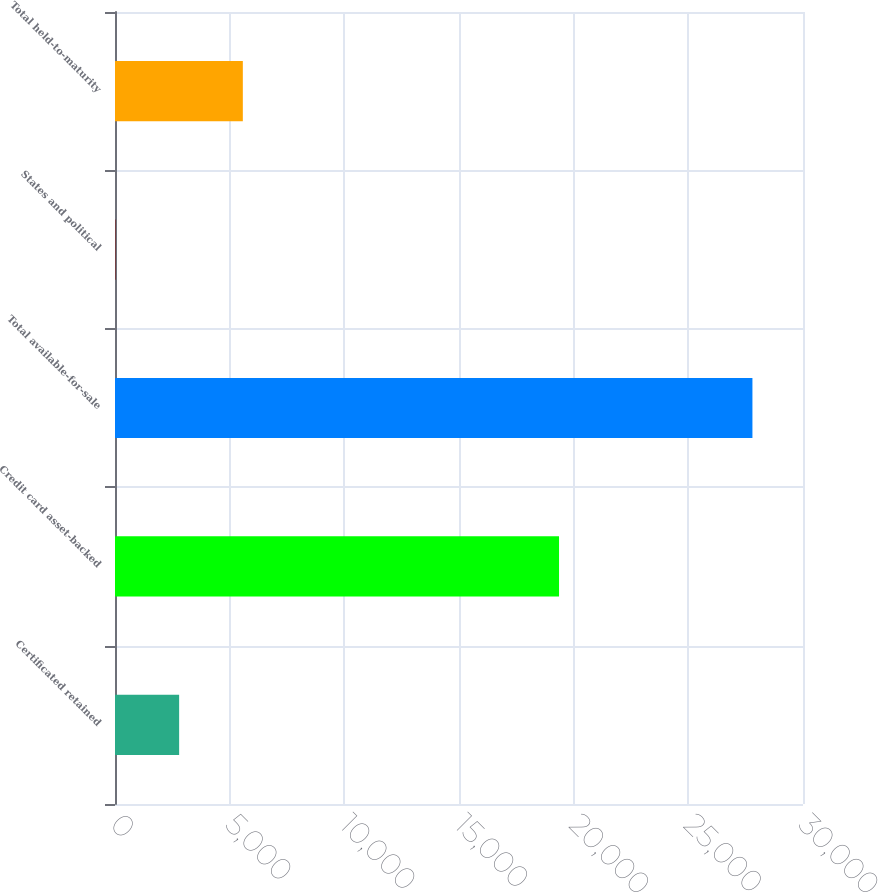Convert chart. <chart><loc_0><loc_0><loc_500><loc_500><bar_chart><fcel>Certificated retained<fcel>Credit card asset-backed<fcel>Total available-for-sale<fcel>States and political<fcel>Total held-to-maturity<nl><fcel>2796.6<fcel>19362<fcel>27795<fcel>19<fcel>5574.2<nl></chart> 